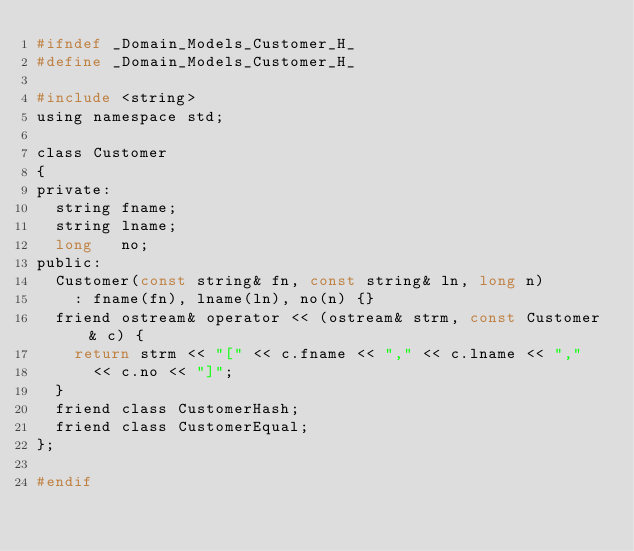<code> <loc_0><loc_0><loc_500><loc_500><_C_>#ifndef _Domain_Models_Customer_H_
#define _Domain_Models_Customer_H_

#include <string>
using namespace std;

class Customer 
{
private:
	string fname;
	string lname;
	long   no;
public:
	Customer(const string& fn, const string& ln, long n)
		: fname(fn), lname(ln), no(n) {}
	friend ostream& operator << (ostream& strm, const Customer& c) {
		return strm << "[" << c.fname << "," << c.lname << ","
			<< c.no << "]";
	}
	friend class CustomerHash;
	friend class CustomerEqual;
};

#endif</code> 